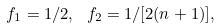<formula> <loc_0><loc_0><loc_500><loc_500>f _ { 1 } = 1 / 2 , \ f _ { 2 } = 1 / [ 2 ( n + 1 ) ] ,</formula> 